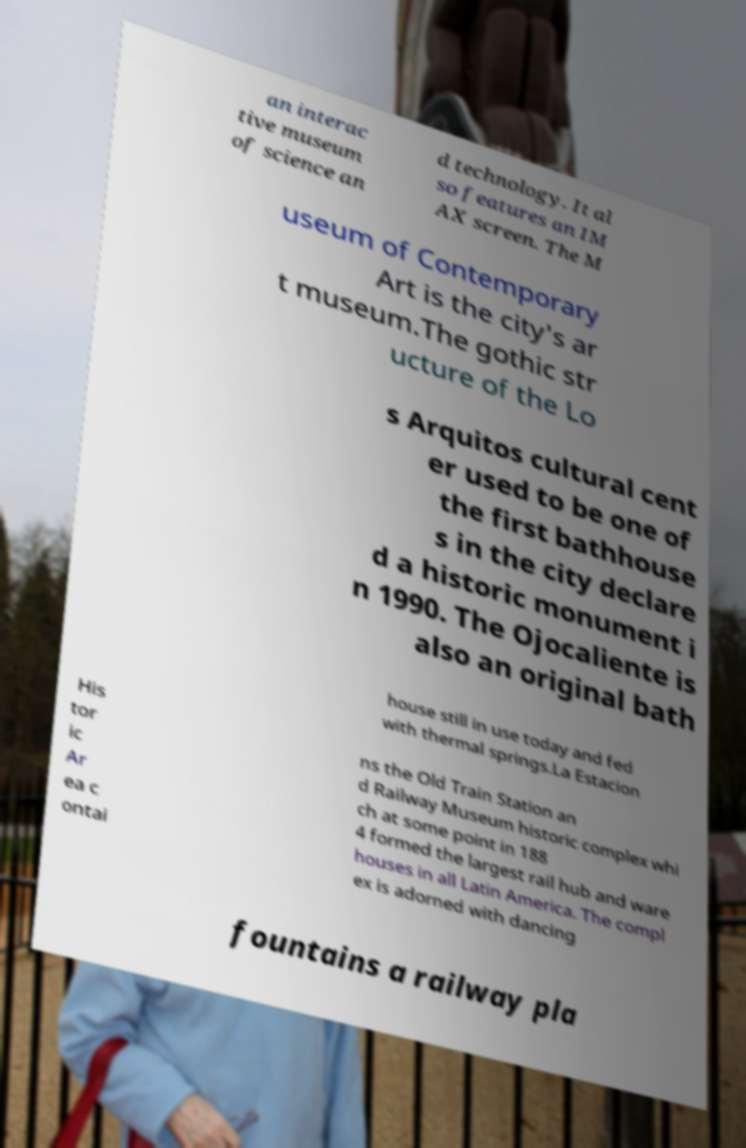Can you accurately transcribe the text from the provided image for me? an interac tive museum of science an d technology. It al so features an IM AX screen. The M useum of Contemporary Art is the city's ar t museum.The gothic str ucture of the Lo s Arquitos cultural cent er used to be one of the first bathhouse s in the city declare d a historic monument i n 1990. The Ojocaliente is also an original bath house still in use today and fed with thermal springs.La Estacion His tor ic Ar ea c ontai ns the Old Train Station an d Railway Museum historic complex whi ch at some point in 188 4 formed the largest rail hub and ware houses in all Latin America. The compl ex is adorned with dancing fountains a railway pla 